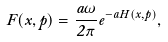Convert formula to latex. <formula><loc_0><loc_0><loc_500><loc_500>F ( x , p ) = \frac { a \omega } { 2 \pi } e ^ { - a H ( x , p ) } ,</formula> 